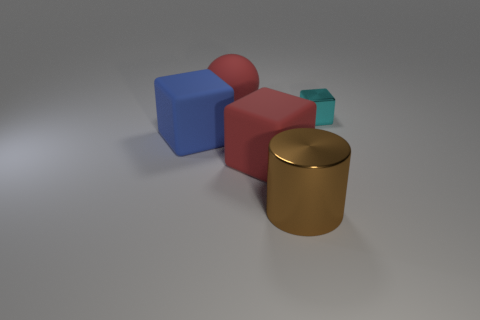Is there anything else that has the same size as the cyan shiny block?
Provide a short and direct response. No. What color is the other matte thing that is the same shape as the large blue matte thing?
Provide a short and direct response. Red. There is a matte object that is left of the red rubber thing that is behind the cyan block; what color is it?
Your answer should be compact. Blue. What is the size of the other red rubber thing that is the same shape as the tiny thing?
Give a very brief answer. Large. What number of brown cylinders have the same material as the cyan thing?
Your response must be concise. 1. There is a big matte cube that is to the right of the large blue matte block; what number of blue matte things are behind it?
Provide a short and direct response. 1. Are there any brown metal cylinders left of the brown metallic cylinder?
Offer a very short reply. No. Is the shape of the metallic object that is behind the large brown cylinder the same as  the blue object?
Ensure brevity in your answer.  Yes. What material is the thing that is the same color as the rubber ball?
Offer a very short reply. Rubber. How many large matte things have the same color as the big rubber sphere?
Your answer should be very brief. 1. 